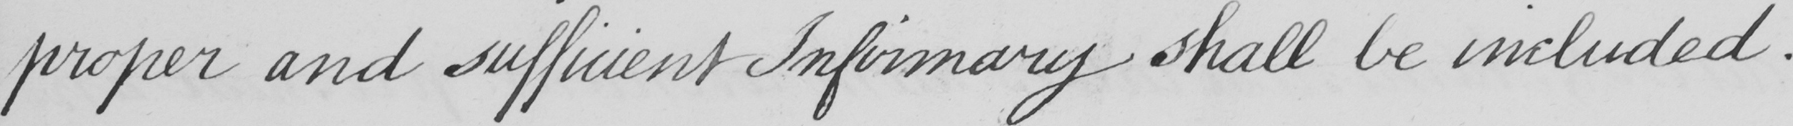Transcribe the text shown in this historical manuscript line. proper and sufficient Infirmary shall be included . 